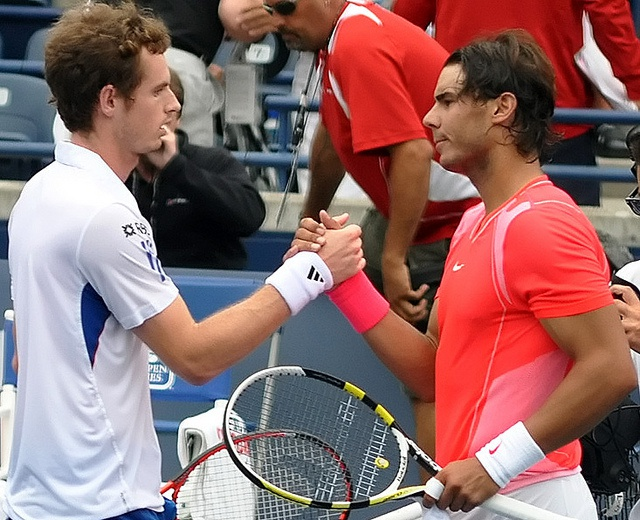Describe the objects in this image and their specific colors. I can see people in black, lavender, brown, and darkgray tones, people in black, salmon, red, brown, and maroon tones, people in black, maroon, red, and brown tones, tennis racket in black, gray, white, and darkgray tones, and people in black, brown, maroon, and lightgray tones in this image. 